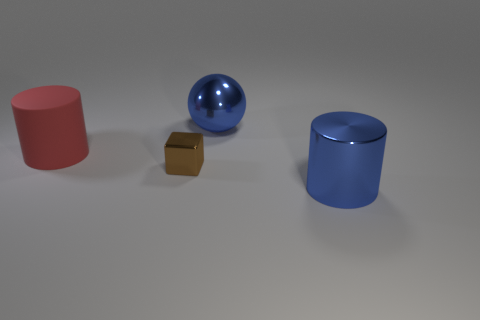The large blue object on the left side of the blue object in front of the tiny brown metallic block is what shape? sphere 